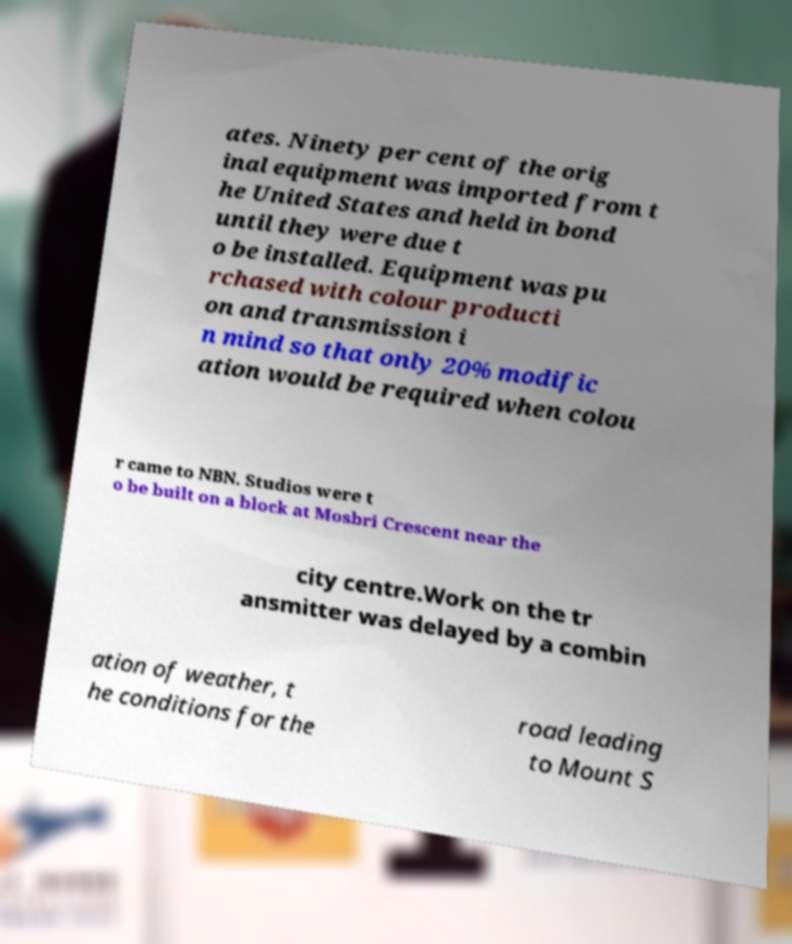Please read and relay the text visible in this image. What does it say? ates. Ninety per cent of the orig inal equipment was imported from t he United States and held in bond until they were due t o be installed. Equipment was pu rchased with colour producti on and transmission i n mind so that only 20% modific ation would be required when colou r came to NBN. Studios were t o be built on a block at Mosbri Crescent near the city centre.Work on the tr ansmitter was delayed by a combin ation of weather, t he conditions for the road leading to Mount S 